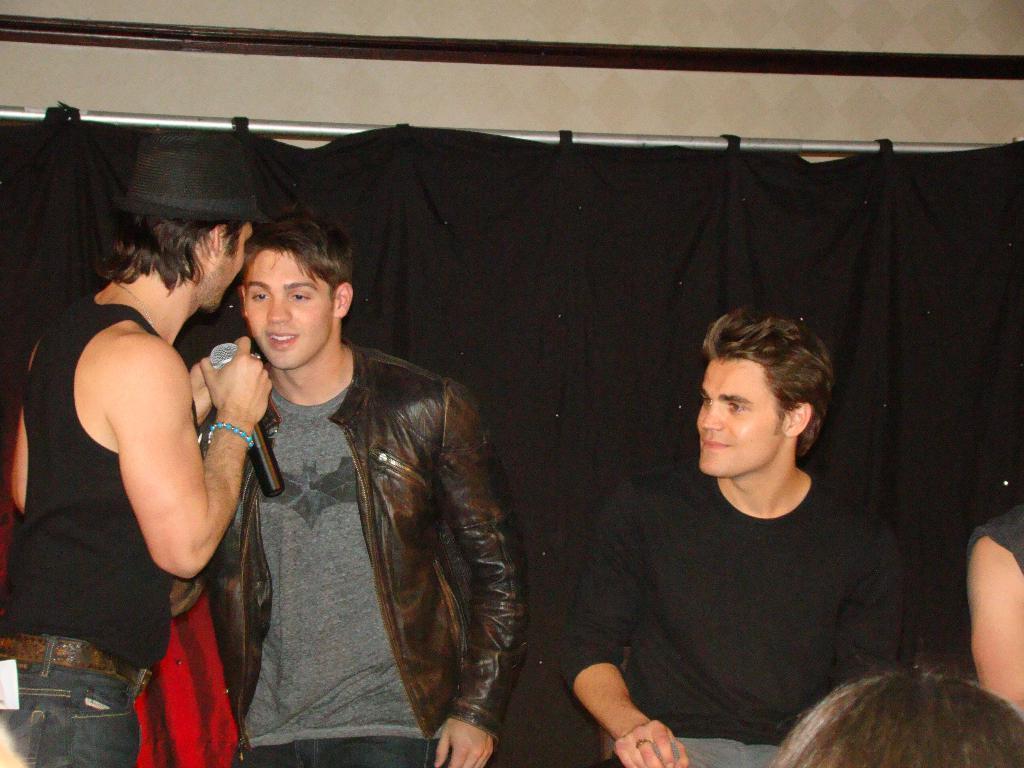Could you give a brief overview of what you see in this image? in this image there are some persons in middle of this image. The left side person is wearing black color t shirt and holding a mic and wearing a black color cap. and the right side person wearing a black color jacket and there is a black color cloth in the background,and there is a person at right side is wearing a black color t shirt and there are some persons at bottom right corner of this image. 